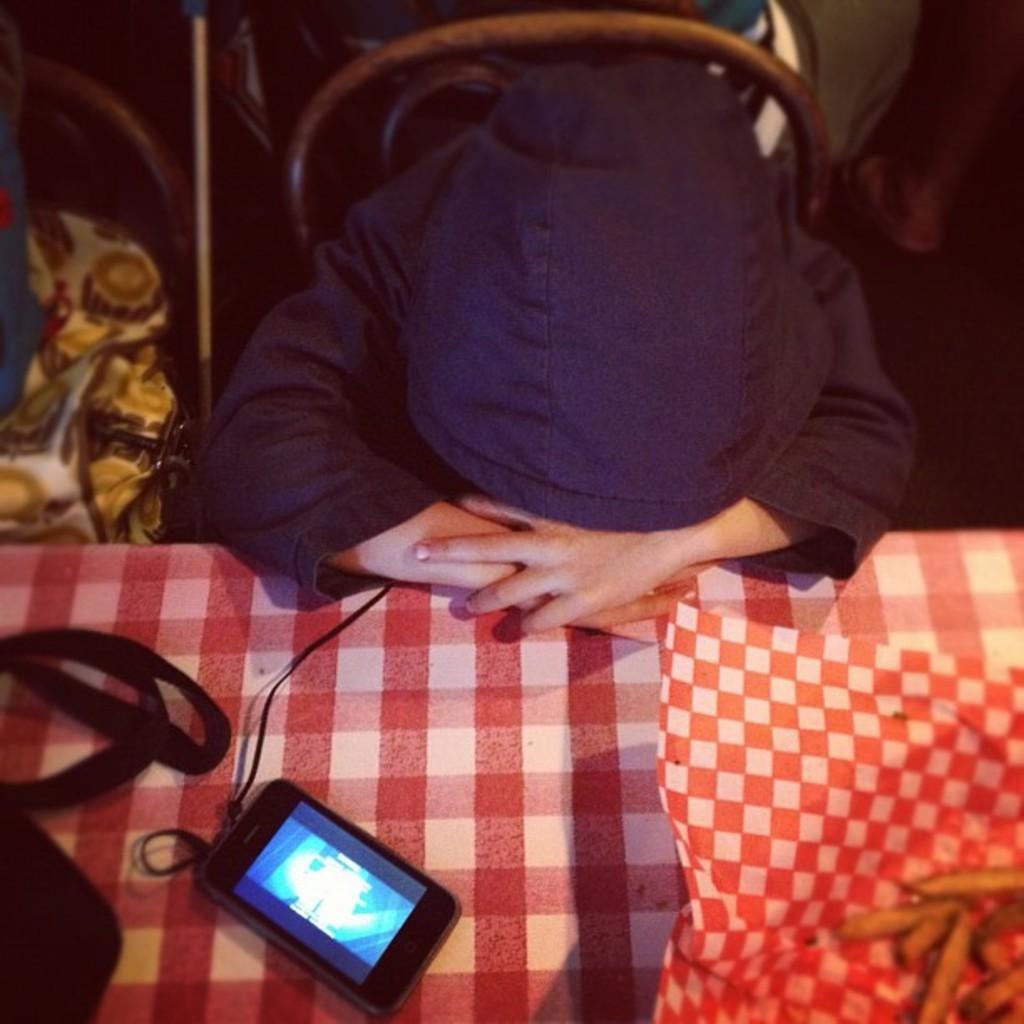In one or two sentences, can you explain what this image depicts? There is a person wearing black jacket and there is a table in front of him which has a mobile phone,wire and some other objects on it. 